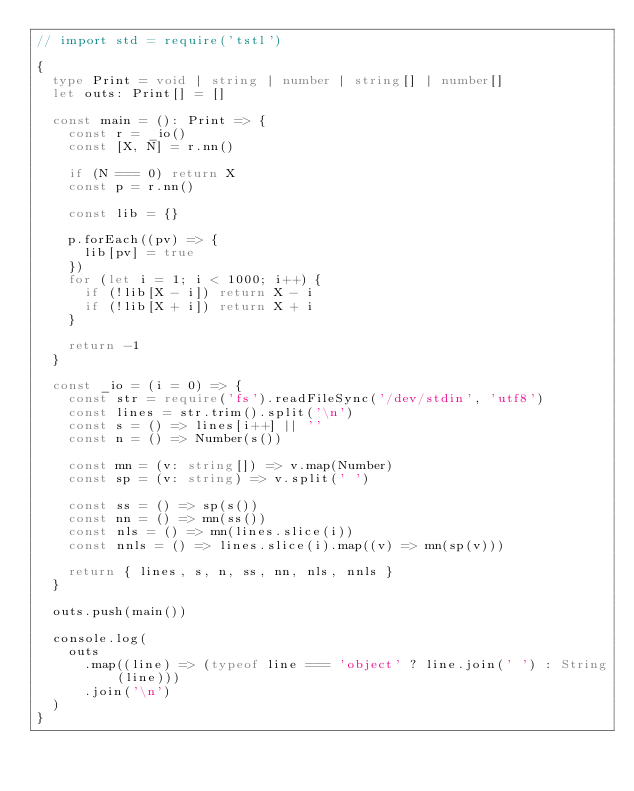<code> <loc_0><loc_0><loc_500><loc_500><_TypeScript_>// import std = require('tstl')

{
  type Print = void | string | number | string[] | number[]
  let outs: Print[] = []

  const main = (): Print => {
    const r = _io()
    const [X, N] = r.nn()

    if (N === 0) return X
    const p = r.nn()

    const lib = {}

    p.forEach((pv) => {
      lib[pv] = true
    })
    for (let i = 1; i < 1000; i++) {
      if (!lib[X - i]) return X - i
      if (!lib[X + i]) return X + i
    }

    return -1
  }

  const _io = (i = 0) => {
    const str = require('fs').readFileSync('/dev/stdin', 'utf8')
    const lines = str.trim().split('\n')
    const s = () => lines[i++] || ''
    const n = () => Number(s())

    const mn = (v: string[]) => v.map(Number)
    const sp = (v: string) => v.split(' ')

    const ss = () => sp(s())
    const nn = () => mn(ss())
    const nls = () => mn(lines.slice(i))
    const nnls = () => lines.slice(i).map((v) => mn(sp(v)))

    return { lines, s, n, ss, nn, nls, nnls }
  }

  outs.push(main())

  console.log(
    outs
      .map((line) => (typeof line === 'object' ? line.join(' ') : String(line)))
      .join('\n')
  )
}
</code> 